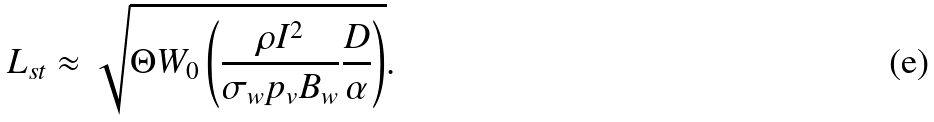Convert formula to latex. <formula><loc_0><loc_0><loc_500><loc_500>L _ { s t } \approx \sqrt { \Theta W _ { 0 } \left ( \frac { \rho I ^ { 2 } } { \sigma _ { w } p _ { v } B _ { w } } \frac { D } { \alpha } \right ) } .</formula> 